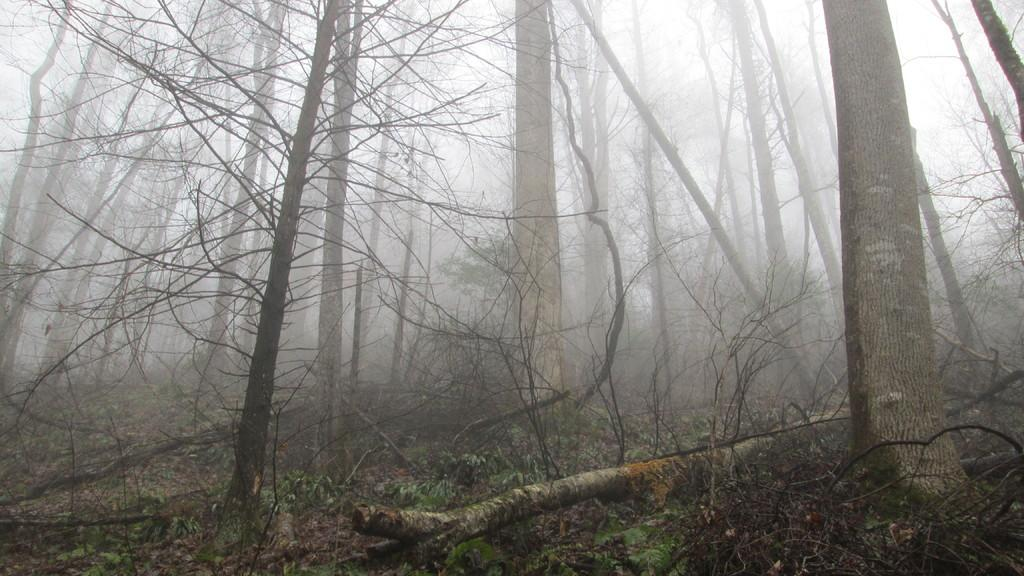What type of vegetation can be seen in the image? There are branches and green leaves in the image. Where are the branches and green leaves located? The branches and green leaves are on the ground. What type of hospital can be seen in the image? There is no hospital present in the image; it features branches and green leaves on the ground. How many pears are visible in the image? There are no pears present in the image. 